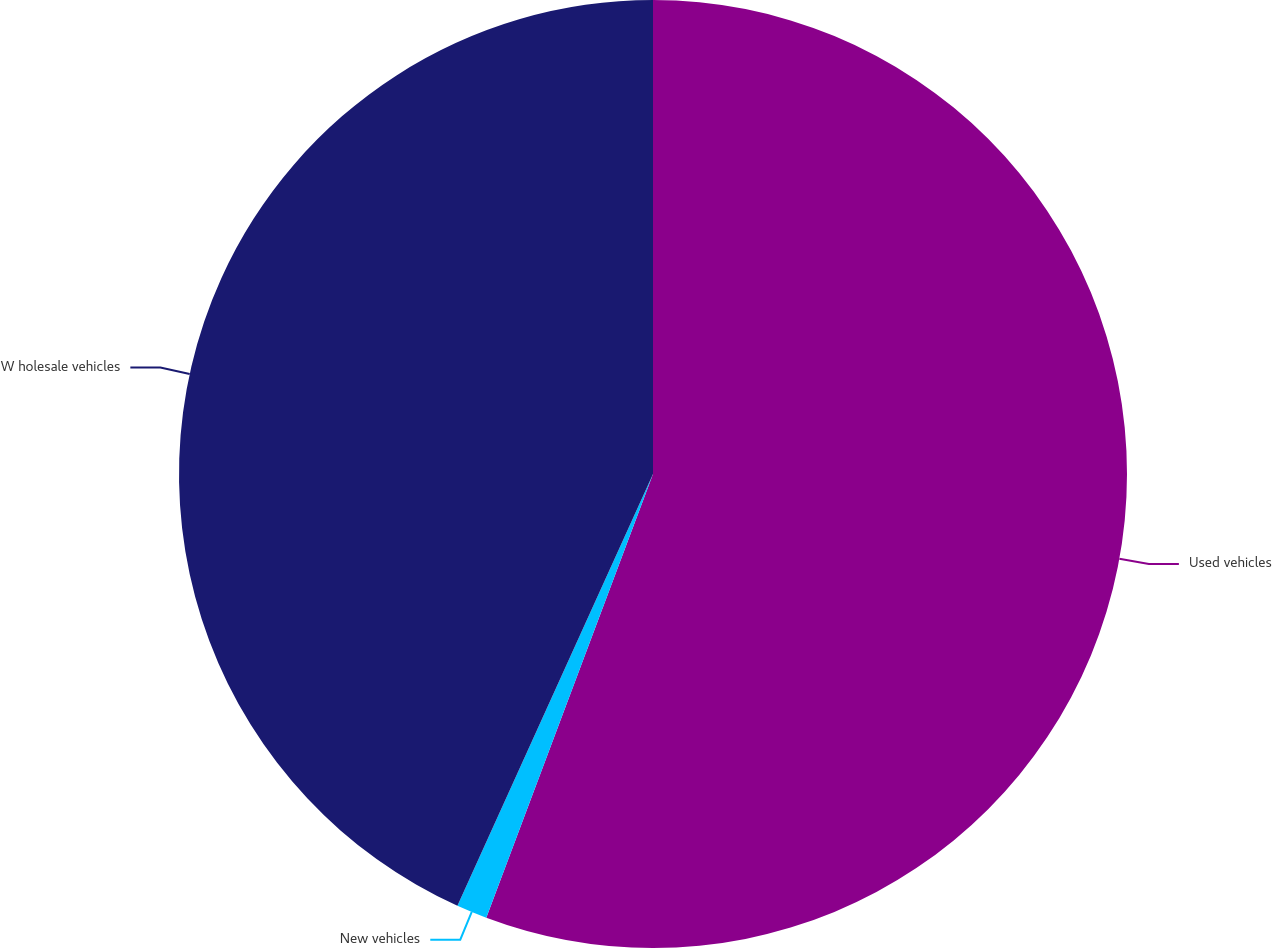Convert chart. <chart><loc_0><loc_0><loc_500><loc_500><pie_chart><fcel>Used vehicles<fcel>New vehicles<fcel>W holesale vehicles<nl><fcel>55.72%<fcel>1.05%<fcel>43.23%<nl></chart> 